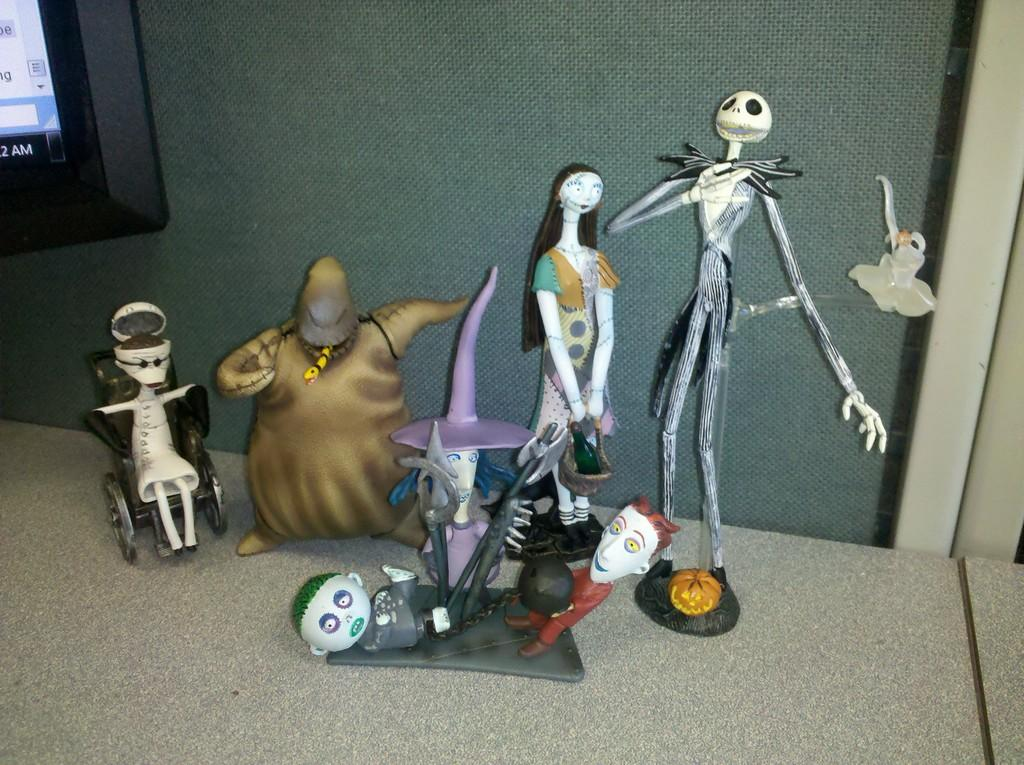What objects are placed on a surface in the image? There are toys placed on a surface in the image. What electronic device is visible in the image? There is a monitor screen at the top left of the image. What type of bat can be seen flying around the toys in the image? There is no bat present in the image; it only features toys and a monitor screen. What language is being spoken by the toys in the image? Toys do not speak any language, so this question cannot be answered. 